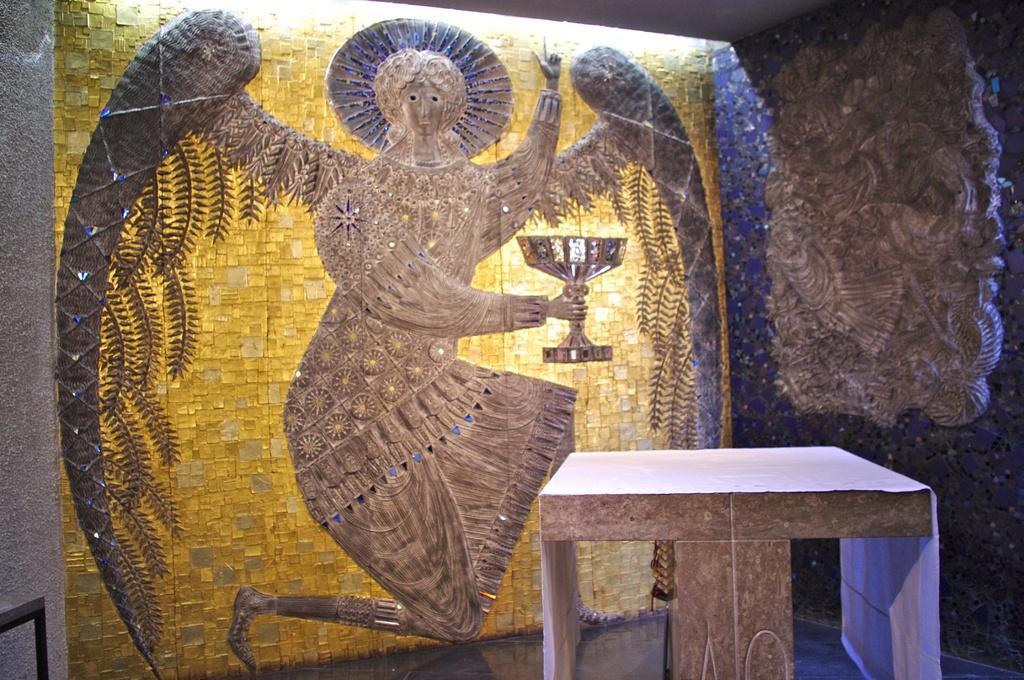In one or two sentences, can you explain what this image depicts? On the left side of this image there is a wall. On the wall there is a painting and also I can see an art. On the right side there is a carving. At the the bottom there is a table placed on the floor. 